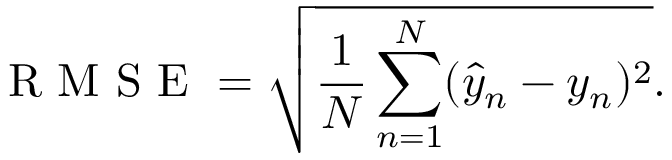Convert formula to latex. <formula><loc_0><loc_0><loc_500><loc_500>R M S E = \sqrt { \frac { 1 } { N } \sum _ { n = 1 } ^ { N } ( \hat { y } _ { n } - y _ { n } ) ^ { 2 } } .</formula> 